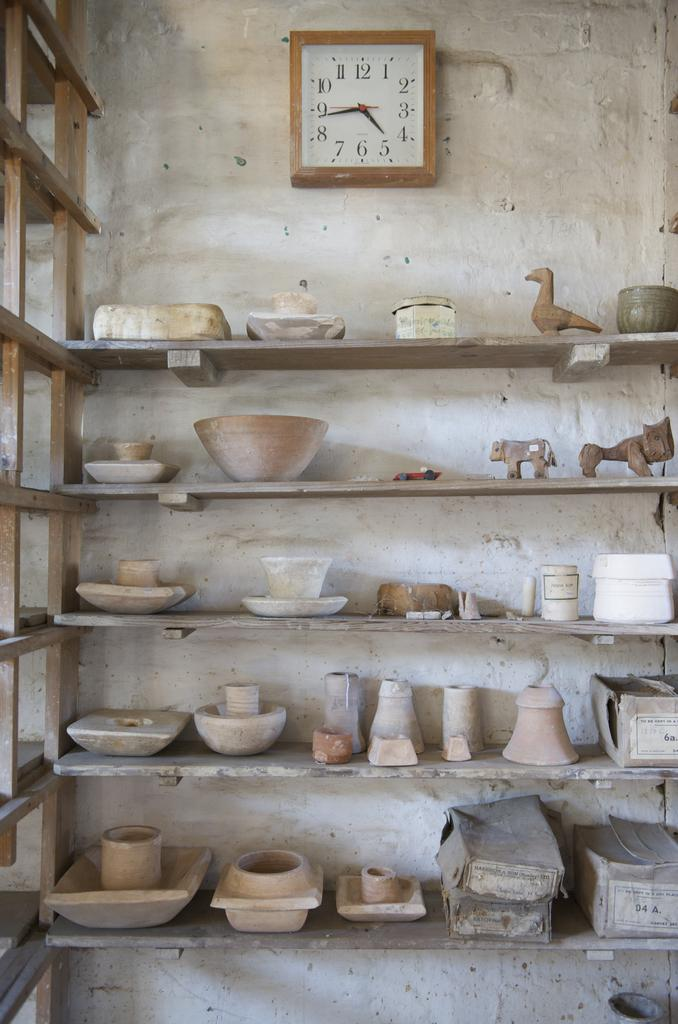<image>
Describe the image concisely. shelves of pottery with one labeled '04 A.' 